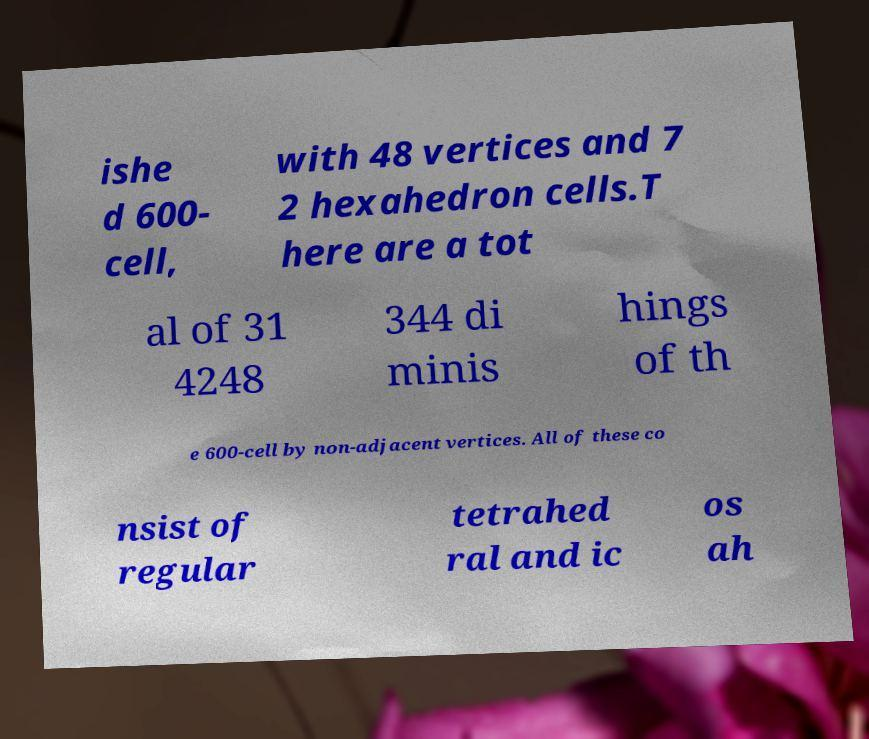There's text embedded in this image that I need extracted. Can you transcribe it verbatim? ishe d 600- cell, with 48 vertices and 7 2 hexahedron cells.T here are a tot al of 31 4248 344 di minis hings of th e 600-cell by non-adjacent vertices. All of these co nsist of regular tetrahed ral and ic os ah 